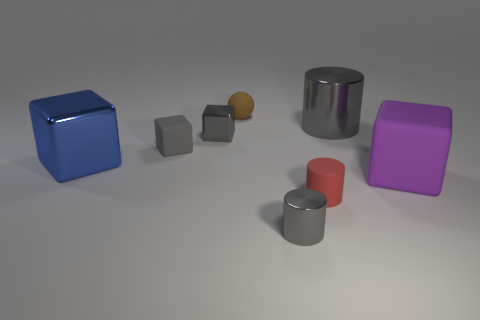Add 2 big shiny balls. How many objects exist? 10 Subtract all balls. How many objects are left? 7 Add 1 tiny gray shiny cubes. How many tiny gray shiny cubes are left? 2 Add 8 cyan metal objects. How many cyan metal objects exist? 8 Subtract 0 purple spheres. How many objects are left? 8 Subtract all blue metal objects. Subtract all purple blocks. How many objects are left? 6 